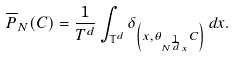<formula> <loc_0><loc_0><loc_500><loc_500>\overline { P } _ { N } ( C ) = \frac { 1 } { T ^ { d } } \int _ { \mathbb { T } ^ { d } } \delta _ { \left ( x , \theta _ { N ^ { \frac { 1 } { d } } x } C \right ) } \, d x .</formula> 